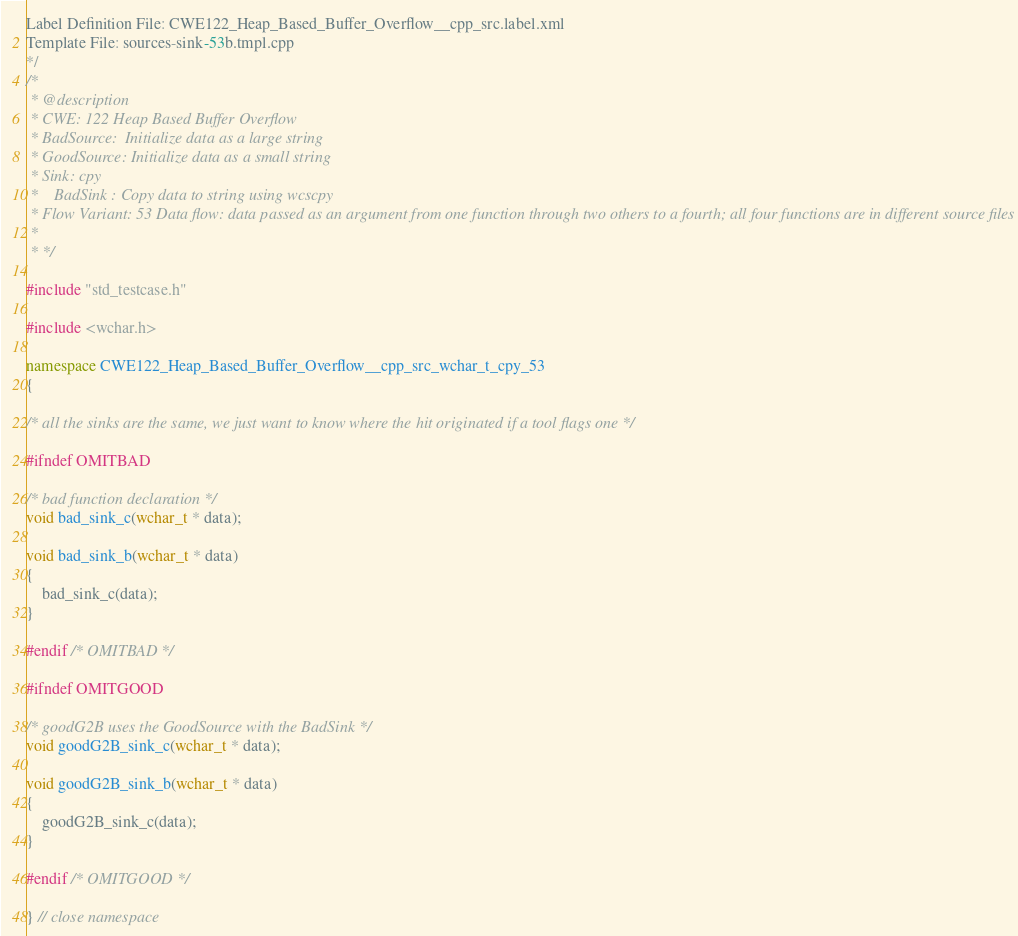Convert code to text. <code><loc_0><loc_0><loc_500><loc_500><_C++_>Label Definition File: CWE122_Heap_Based_Buffer_Overflow__cpp_src.label.xml
Template File: sources-sink-53b.tmpl.cpp
*/
/*
 * @description
 * CWE: 122 Heap Based Buffer Overflow
 * BadSource:  Initialize data as a large string
 * GoodSource: Initialize data as a small string
 * Sink: cpy
 *    BadSink : Copy data to string using wcscpy
 * Flow Variant: 53 Data flow: data passed as an argument from one function through two others to a fourth; all four functions are in different source files
 *
 * */

#include "std_testcase.h"

#include <wchar.h>

namespace CWE122_Heap_Based_Buffer_Overflow__cpp_src_wchar_t_cpy_53
{

/* all the sinks are the same, we just want to know where the hit originated if a tool flags one */

#ifndef OMITBAD

/* bad function declaration */
void bad_sink_c(wchar_t * data);

void bad_sink_b(wchar_t * data)
{
    bad_sink_c(data);
}

#endif /* OMITBAD */

#ifndef OMITGOOD

/* goodG2B uses the GoodSource with the BadSink */
void goodG2B_sink_c(wchar_t * data);

void goodG2B_sink_b(wchar_t * data)
{
    goodG2B_sink_c(data);
}

#endif /* OMITGOOD */

} // close namespace
</code> 